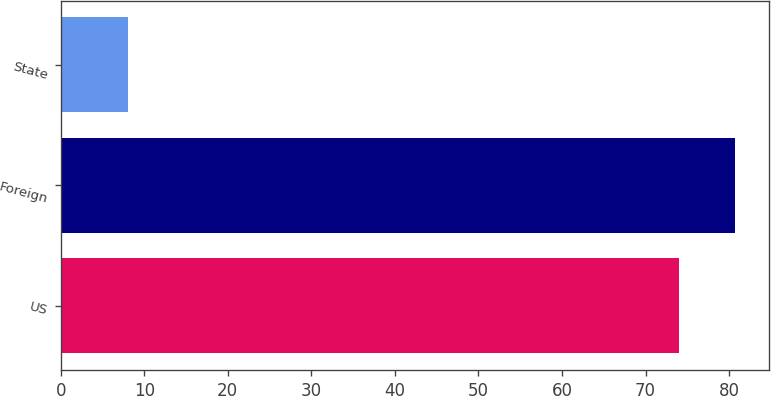Convert chart to OTSL. <chart><loc_0><loc_0><loc_500><loc_500><bar_chart><fcel>US<fcel>Foreign<fcel>State<nl><fcel>74<fcel>80.7<fcel>8<nl></chart> 